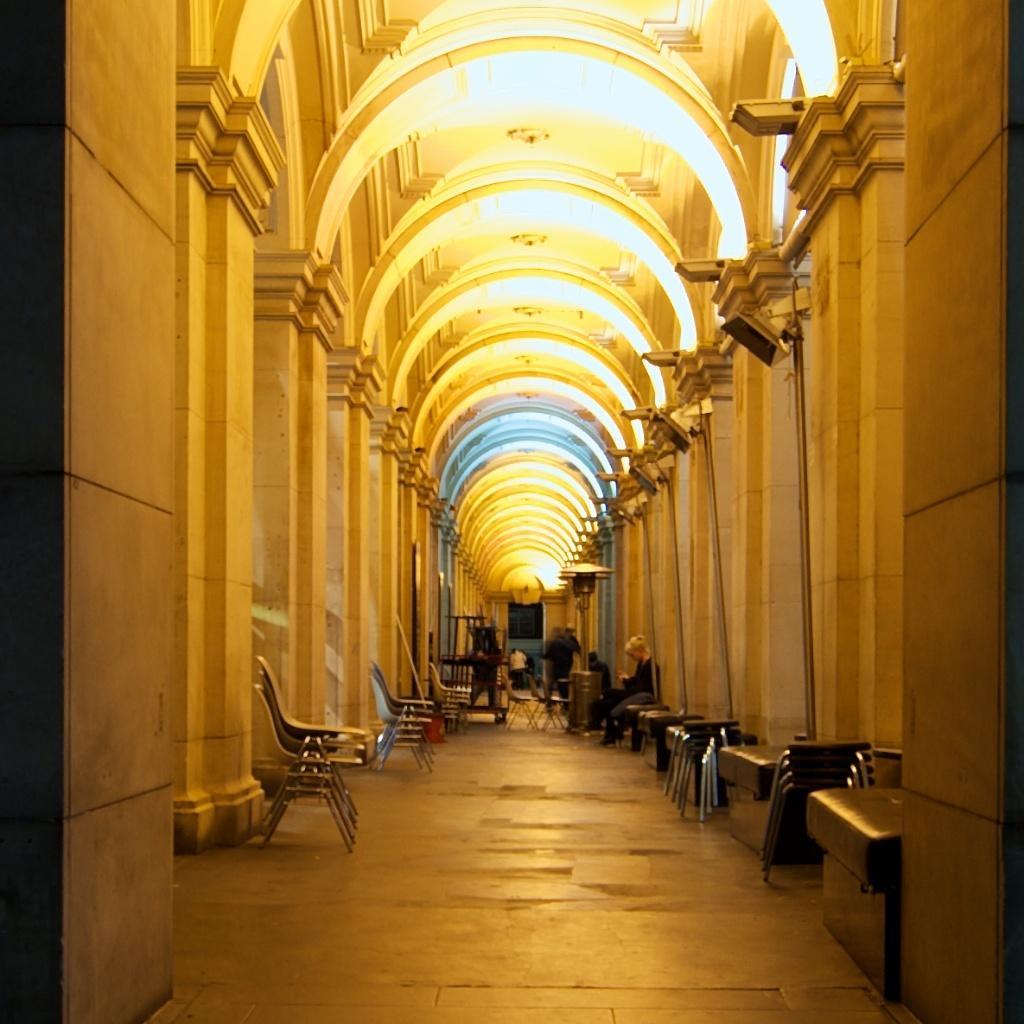Can you describe this image briefly? In this image on the right side there are chairs and there are persons sitting and standing. On the left side there are empty chairs and there is a man standing and there are walls. On the top there are arches. 